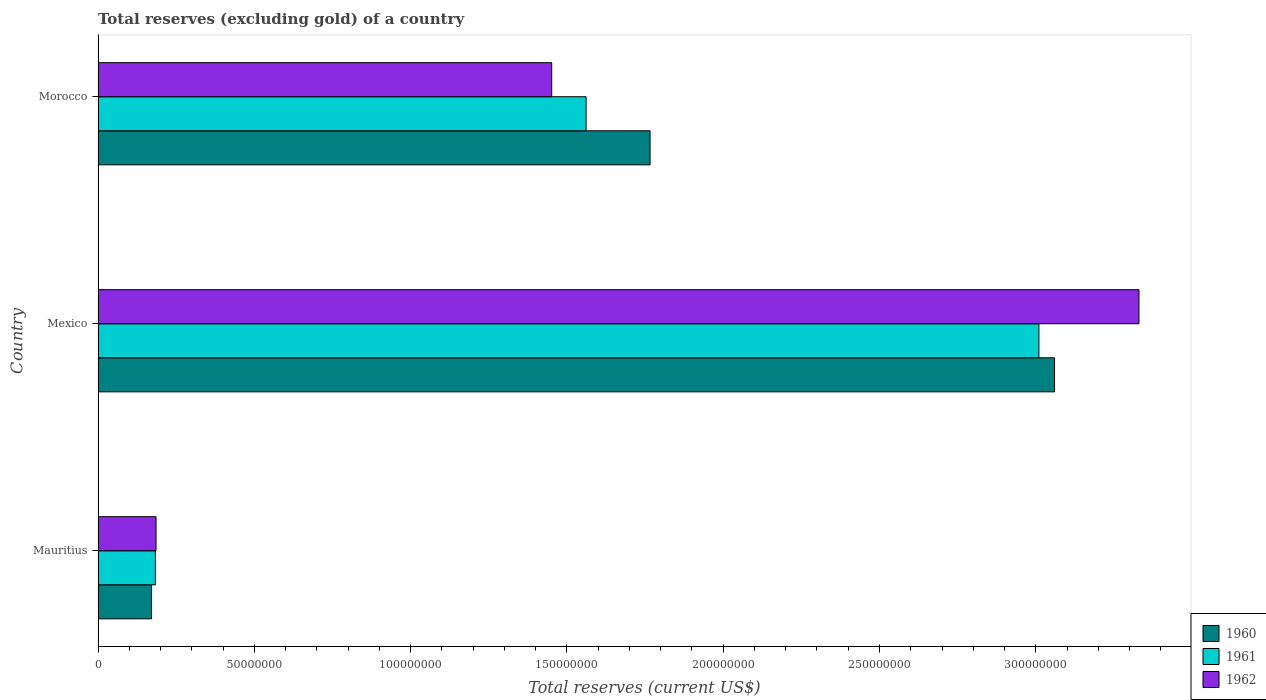How many different coloured bars are there?
Give a very brief answer. 3. Are the number of bars per tick equal to the number of legend labels?
Your answer should be very brief. Yes. Are the number of bars on each tick of the Y-axis equal?
Offer a terse response. Yes. How many bars are there on the 2nd tick from the top?
Provide a succinct answer. 3. How many bars are there on the 3rd tick from the bottom?
Keep it short and to the point. 3. In how many cases, is the number of bars for a given country not equal to the number of legend labels?
Offer a terse response. 0. What is the total reserves (excluding gold) in 1960 in Morocco?
Give a very brief answer. 1.77e+08. Across all countries, what is the maximum total reserves (excluding gold) in 1962?
Make the answer very short. 3.33e+08. Across all countries, what is the minimum total reserves (excluding gold) in 1961?
Your answer should be compact. 1.83e+07. In which country was the total reserves (excluding gold) in 1962 maximum?
Your answer should be compact. Mexico. In which country was the total reserves (excluding gold) in 1960 minimum?
Keep it short and to the point. Mauritius. What is the total total reserves (excluding gold) in 1960 in the graph?
Your response must be concise. 5.00e+08. What is the difference between the total reserves (excluding gold) in 1962 in Mauritius and that in Morocco?
Make the answer very short. -1.27e+08. What is the difference between the total reserves (excluding gold) in 1961 in Mauritius and the total reserves (excluding gold) in 1962 in Morocco?
Provide a succinct answer. -1.27e+08. What is the average total reserves (excluding gold) in 1961 per country?
Your answer should be compact. 1.58e+08. What is the difference between the total reserves (excluding gold) in 1960 and total reserves (excluding gold) in 1962 in Mexico?
Make the answer very short. -2.70e+07. In how many countries, is the total reserves (excluding gold) in 1962 greater than 130000000 US$?
Ensure brevity in your answer.  2. What is the ratio of the total reserves (excluding gold) in 1960 in Mauritius to that in Mexico?
Your response must be concise. 0.06. Is the total reserves (excluding gold) in 1960 in Mauritius less than that in Mexico?
Your answer should be very brief. Yes. What is the difference between the highest and the second highest total reserves (excluding gold) in 1962?
Provide a succinct answer. 1.88e+08. What is the difference between the highest and the lowest total reserves (excluding gold) in 1961?
Your answer should be compact. 2.83e+08. In how many countries, is the total reserves (excluding gold) in 1960 greater than the average total reserves (excluding gold) in 1960 taken over all countries?
Make the answer very short. 2. Is it the case that in every country, the sum of the total reserves (excluding gold) in 1961 and total reserves (excluding gold) in 1962 is greater than the total reserves (excluding gold) in 1960?
Provide a short and direct response. Yes. What is the difference between two consecutive major ticks on the X-axis?
Make the answer very short. 5.00e+07. Are the values on the major ticks of X-axis written in scientific E-notation?
Ensure brevity in your answer.  No. Where does the legend appear in the graph?
Your answer should be compact. Bottom right. What is the title of the graph?
Make the answer very short. Total reserves (excluding gold) of a country. What is the label or title of the X-axis?
Make the answer very short. Total reserves (current US$). What is the label or title of the Y-axis?
Your answer should be compact. Country. What is the Total reserves (current US$) of 1960 in Mauritius?
Provide a succinct answer. 1.71e+07. What is the Total reserves (current US$) of 1961 in Mauritius?
Your answer should be very brief. 1.83e+07. What is the Total reserves (current US$) of 1962 in Mauritius?
Ensure brevity in your answer.  1.86e+07. What is the Total reserves (current US$) in 1960 in Mexico?
Provide a short and direct response. 3.06e+08. What is the Total reserves (current US$) in 1961 in Mexico?
Provide a short and direct response. 3.01e+08. What is the Total reserves (current US$) in 1962 in Mexico?
Provide a short and direct response. 3.33e+08. What is the Total reserves (current US$) in 1960 in Morocco?
Your response must be concise. 1.77e+08. What is the Total reserves (current US$) of 1961 in Morocco?
Your response must be concise. 1.56e+08. What is the Total reserves (current US$) in 1962 in Morocco?
Keep it short and to the point. 1.45e+08. Across all countries, what is the maximum Total reserves (current US$) of 1960?
Give a very brief answer. 3.06e+08. Across all countries, what is the maximum Total reserves (current US$) in 1961?
Provide a short and direct response. 3.01e+08. Across all countries, what is the maximum Total reserves (current US$) of 1962?
Provide a succinct answer. 3.33e+08. Across all countries, what is the minimum Total reserves (current US$) of 1960?
Your answer should be very brief. 1.71e+07. Across all countries, what is the minimum Total reserves (current US$) of 1961?
Provide a short and direct response. 1.83e+07. Across all countries, what is the minimum Total reserves (current US$) of 1962?
Offer a very short reply. 1.86e+07. What is the total Total reserves (current US$) of 1960 in the graph?
Provide a succinct answer. 5.00e+08. What is the total Total reserves (current US$) of 1961 in the graph?
Your answer should be compact. 4.75e+08. What is the total Total reserves (current US$) of 1962 in the graph?
Make the answer very short. 4.97e+08. What is the difference between the Total reserves (current US$) in 1960 in Mauritius and that in Mexico?
Your answer should be compact. -2.89e+08. What is the difference between the Total reserves (current US$) in 1961 in Mauritius and that in Mexico?
Your answer should be very brief. -2.83e+08. What is the difference between the Total reserves (current US$) of 1962 in Mauritius and that in Mexico?
Make the answer very short. -3.14e+08. What is the difference between the Total reserves (current US$) in 1960 in Mauritius and that in Morocco?
Provide a succinct answer. -1.59e+08. What is the difference between the Total reserves (current US$) of 1961 in Mauritius and that in Morocco?
Your response must be concise. -1.38e+08. What is the difference between the Total reserves (current US$) of 1962 in Mauritius and that in Morocco?
Provide a succinct answer. -1.27e+08. What is the difference between the Total reserves (current US$) of 1960 in Mexico and that in Morocco?
Provide a succinct answer. 1.29e+08. What is the difference between the Total reserves (current US$) of 1961 in Mexico and that in Morocco?
Provide a succinct answer. 1.45e+08. What is the difference between the Total reserves (current US$) of 1962 in Mexico and that in Morocco?
Keep it short and to the point. 1.88e+08. What is the difference between the Total reserves (current US$) of 1960 in Mauritius and the Total reserves (current US$) of 1961 in Mexico?
Your answer should be very brief. -2.84e+08. What is the difference between the Total reserves (current US$) in 1960 in Mauritius and the Total reserves (current US$) in 1962 in Mexico?
Give a very brief answer. -3.16e+08. What is the difference between the Total reserves (current US$) of 1961 in Mauritius and the Total reserves (current US$) of 1962 in Mexico?
Offer a terse response. -3.15e+08. What is the difference between the Total reserves (current US$) in 1960 in Mauritius and the Total reserves (current US$) in 1961 in Morocco?
Your response must be concise. -1.39e+08. What is the difference between the Total reserves (current US$) in 1960 in Mauritius and the Total reserves (current US$) in 1962 in Morocco?
Give a very brief answer. -1.28e+08. What is the difference between the Total reserves (current US$) in 1961 in Mauritius and the Total reserves (current US$) in 1962 in Morocco?
Your answer should be compact. -1.27e+08. What is the difference between the Total reserves (current US$) in 1960 in Mexico and the Total reserves (current US$) in 1961 in Morocco?
Provide a succinct answer. 1.50e+08. What is the difference between the Total reserves (current US$) in 1960 in Mexico and the Total reserves (current US$) in 1962 in Morocco?
Provide a short and direct response. 1.61e+08. What is the difference between the Total reserves (current US$) of 1961 in Mexico and the Total reserves (current US$) of 1962 in Morocco?
Offer a terse response. 1.56e+08. What is the average Total reserves (current US$) in 1960 per country?
Give a very brief answer. 1.67e+08. What is the average Total reserves (current US$) of 1961 per country?
Provide a short and direct response. 1.58e+08. What is the average Total reserves (current US$) in 1962 per country?
Offer a very short reply. 1.66e+08. What is the difference between the Total reserves (current US$) in 1960 and Total reserves (current US$) in 1961 in Mauritius?
Provide a succinct answer. -1.22e+06. What is the difference between the Total reserves (current US$) in 1960 and Total reserves (current US$) in 1962 in Mauritius?
Offer a terse response. -1.43e+06. What is the difference between the Total reserves (current US$) of 1961 and Total reserves (current US$) of 1962 in Mauritius?
Offer a terse response. -2.10e+05. What is the difference between the Total reserves (current US$) in 1960 and Total reserves (current US$) in 1961 in Mexico?
Make the answer very short. 5.00e+06. What is the difference between the Total reserves (current US$) of 1960 and Total reserves (current US$) of 1962 in Mexico?
Provide a short and direct response. -2.70e+07. What is the difference between the Total reserves (current US$) in 1961 and Total reserves (current US$) in 1962 in Mexico?
Your answer should be very brief. -3.20e+07. What is the difference between the Total reserves (current US$) of 1960 and Total reserves (current US$) of 1961 in Morocco?
Provide a succinct answer. 2.05e+07. What is the difference between the Total reserves (current US$) in 1960 and Total reserves (current US$) in 1962 in Morocco?
Offer a terse response. 3.15e+07. What is the difference between the Total reserves (current US$) in 1961 and Total reserves (current US$) in 1962 in Morocco?
Give a very brief answer. 1.10e+07. What is the ratio of the Total reserves (current US$) of 1960 in Mauritius to that in Mexico?
Offer a terse response. 0.06. What is the ratio of the Total reserves (current US$) of 1961 in Mauritius to that in Mexico?
Provide a succinct answer. 0.06. What is the ratio of the Total reserves (current US$) of 1962 in Mauritius to that in Mexico?
Provide a succinct answer. 0.06. What is the ratio of the Total reserves (current US$) in 1960 in Mauritius to that in Morocco?
Make the answer very short. 0.1. What is the ratio of the Total reserves (current US$) in 1961 in Mauritius to that in Morocco?
Keep it short and to the point. 0.12. What is the ratio of the Total reserves (current US$) in 1962 in Mauritius to that in Morocco?
Provide a short and direct response. 0.13. What is the ratio of the Total reserves (current US$) of 1960 in Mexico to that in Morocco?
Provide a succinct answer. 1.73. What is the ratio of the Total reserves (current US$) in 1961 in Mexico to that in Morocco?
Your answer should be very brief. 1.93. What is the ratio of the Total reserves (current US$) of 1962 in Mexico to that in Morocco?
Give a very brief answer. 2.29. What is the difference between the highest and the second highest Total reserves (current US$) in 1960?
Offer a very short reply. 1.29e+08. What is the difference between the highest and the second highest Total reserves (current US$) of 1961?
Provide a short and direct response. 1.45e+08. What is the difference between the highest and the second highest Total reserves (current US$) of 1962?
Give a very brief answer. 1.88e+08. What is the difference between the highest and the lowest Total reserves (current US$) in 1960?
Provide a short and direct response. 2.89e+08. What is the difference between the highest and the lowest Total reserves (current US$) of 1961?
Make the answer very short. 2.83e+08. What is the difference between the highest and the lowest Total reserves (current US$) of 1962?
Keep it short and to the point. 3.14e+08. 